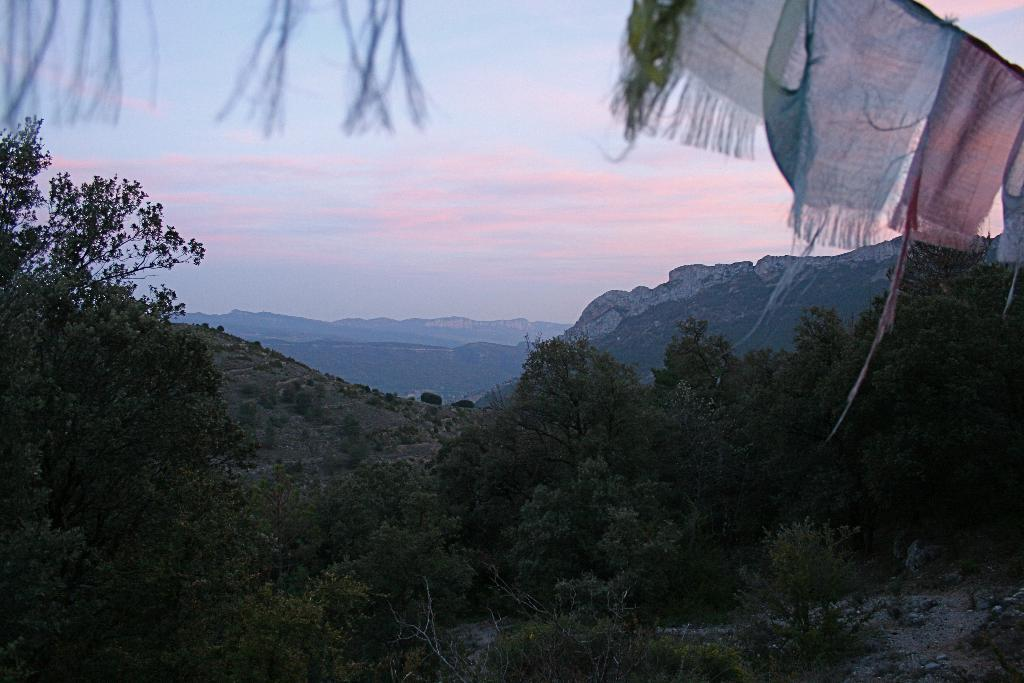What type of vegetation can be seen in the image? There are trees in the image. What is hanging at the top of the image? Clothes are hanging at the top of the image. What can be seen in the distance in the image? There are mountains in the background of the image. What is visible at the top of the image? The sky is visible at the top of the image. Where is the nail used to hang the calendar in the image? There is no nail or calendar present in the image. What type of pencil is being used to draw the mountains in the image? There is no pencil or drawing of the mountains in the image; the mountains are a natural feature in the background. 